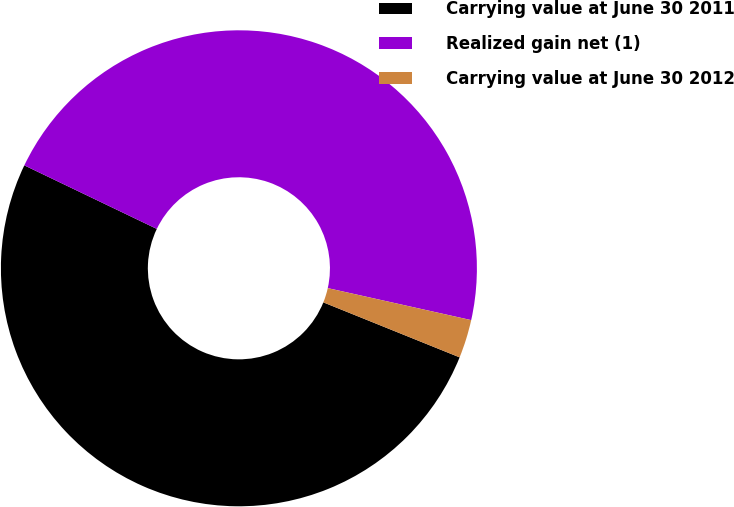Convert chart. <chart><loc_0><loc_0><loc_500><loc_500><pie_chart><fcel>Carrying value at June 30 2011<fcel>Realized gain net (1)<fcel>Carrying value at June 30 2012<nl><fcel>51.01%<fcel>46.37%<fcel>2.61%<nl></chart> 